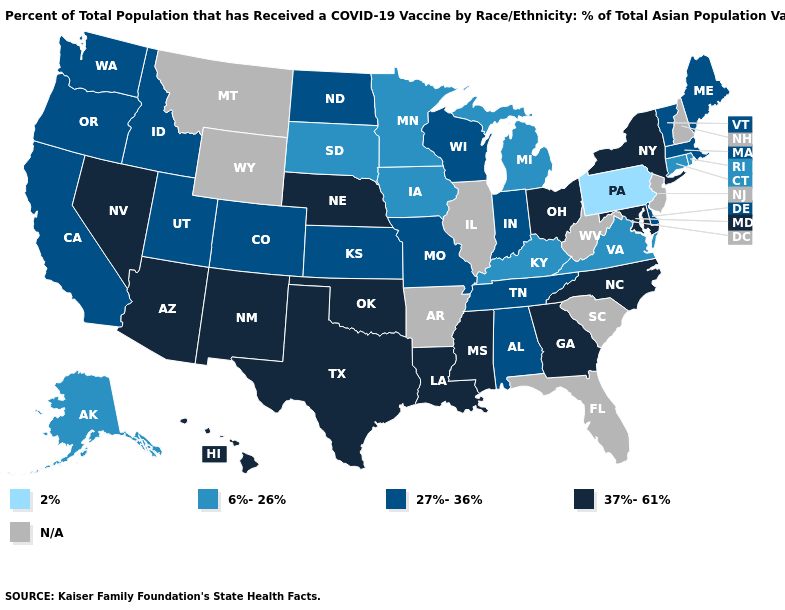What is the value of Ohio?
Answer briefly. 37%-61%. What is the value of South Dakota?
Be succinct. 6%-26%. What is the highest value in the West ?
Give a very brief answer. 37%-61%. What is the value of Maine?
Write a very short answer. 27%-36%. What is the lowest value in states that border Missouri?
Answer briefly. 6%-26%. What is the value of New Jersey?
Short answer required. N/A. Does the map have missing data?
Keep it brief. Yes. What is the lowest value in states that border Michigan?
Give a very brief answer. 27%-36%. Which states have the lowest value in the Northeast?
Write a very short answer. Pennsylvania. What is the highest value in the South ?
Concise answer only. 37%-61%. What is the value of Iowa?
Give a very brief answer. 6%-26%. What is the value of Nevada?
Answer briefly. 37%-61%. What is the lowest value in the Northeast?
Short answer required. 2%. What is the value of Iowa?
Short answer required. 6%-26%. 